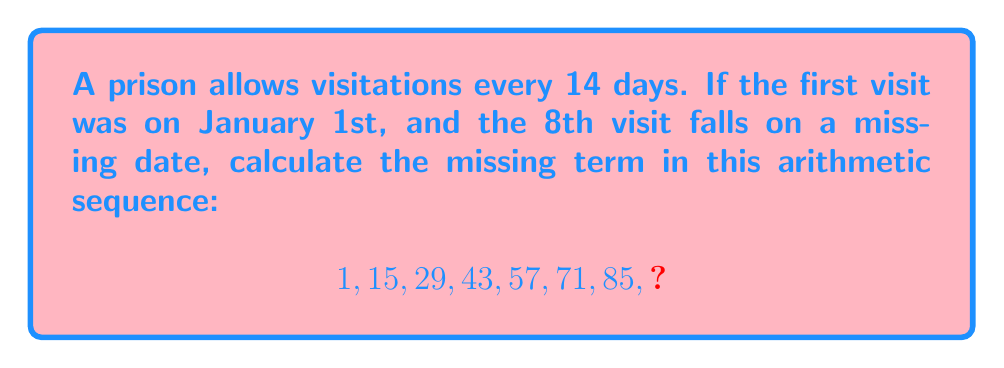What is the answer to this math problem? To solve this problem, let's follow these steps:

1) First, we need to identify the common difference in the arithmetic sequence. We can do this by subtracting any term from the subsequent term:

   $15 - 1 = 14$
   $29 - 15 = 14$
   $43 - 29 = 14$

   The common difference is 14, which matches the given visitation schedule.

2) Now that we've confirmed the sequence, we can find the 8th term by adding the common difference to the 7th term:

   $85 + 14 = 99$

3) To verify, we can use the arithmetic sequence formula:
   
   $a_n = a_1 + (n-1)d$

   Where $a_n$ is the nth term, $a_1$ is the first term, n is the position of the term, and d is the common difference.

4) Plugging in our values:

   $a_8 = 1 + (8-1)14$
   $a_8 = 1 + (7)14$
   $a_8 = 1 + 98$
   $a_8 = 99$

This confirms our calculation.

5) Therefore, the 8th visit would be 99 days after January 1st.
Answer: 99 